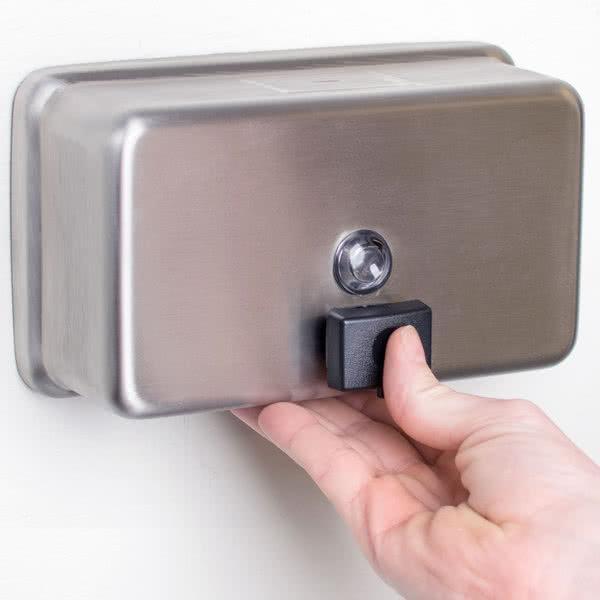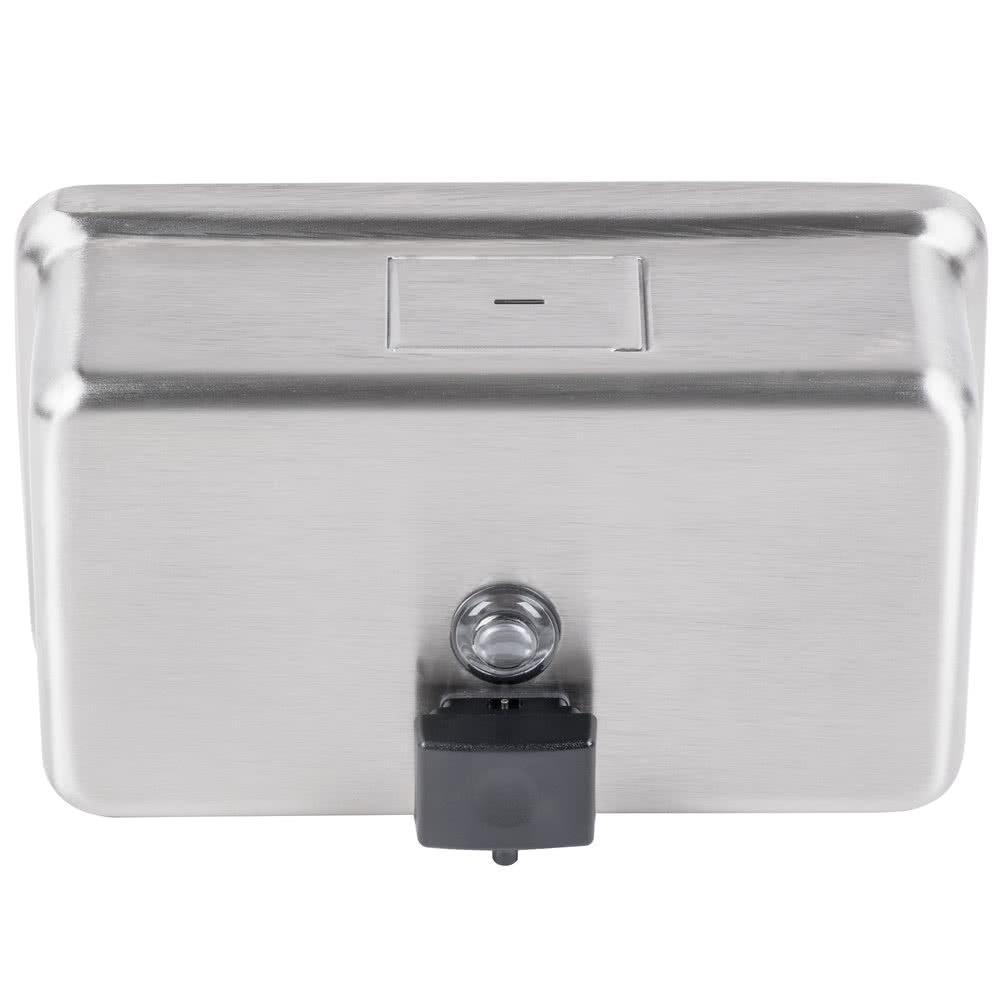The first image is the image on the left, the second image is the image on the right. For the images shown, is this caption "The object in the image on the left is turned toward the right." true? Answer yes or no. Yes. 